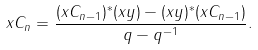Convert formula to latex. <formula><loc_0><loc_0><loc_500><loc_500>& x C _ { n } = \frac { ( x C _ { n - 1 } ) ^ { * } ( x y ) - ( x y ) ^ { * } ( x C _ { n - 1 } ) } { q - q ^ { - 1 } } .</formula> 